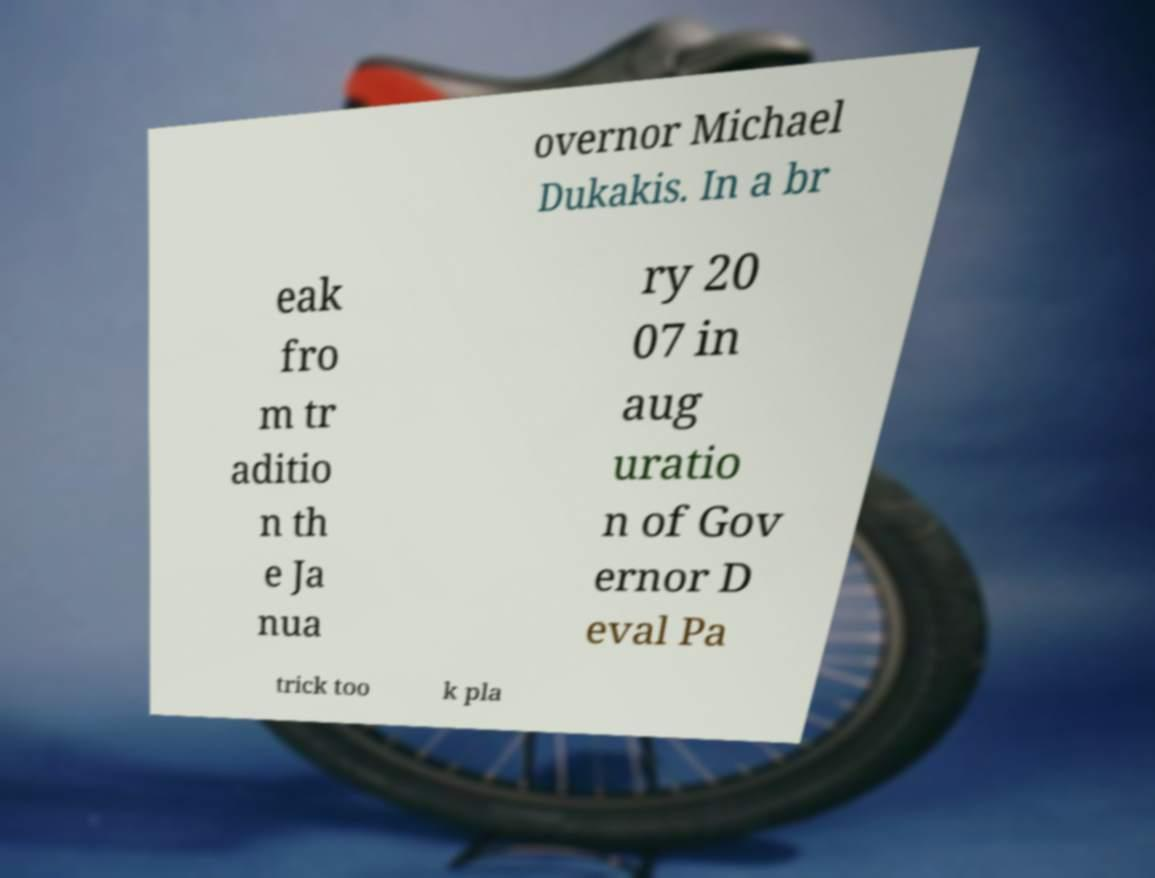Could you extract and type out the text from this image? overnor Michael Dukakis. In a br eak fro m tr aditio n th e Ja nua ry 20 07 in aug uratio n of Gov ernor D eval Pa trick too k pla 